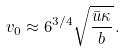<formula> <loc_0><loc_0><loc_500><loc_500>v _ { 0 } \approx 6 ^ { 3 / 4 } \sqrt { \frac { \bar { u } \kappa } { b } } \, .</formula> 